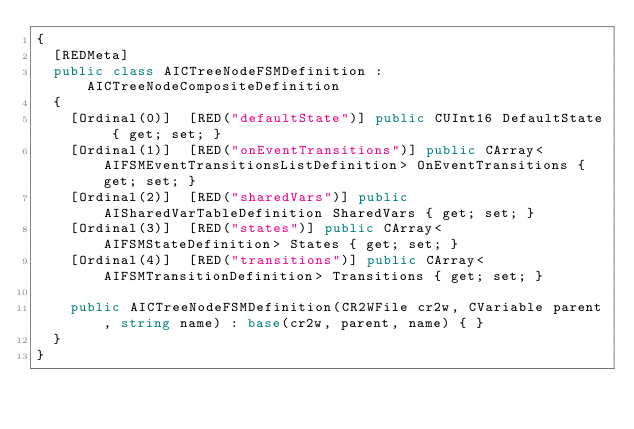<code> <loc_0><loc_0><loc_500><loc_500><_C#_>{
	[REDMeta]
	public class AICTreeNodeFSMDefinition : AICTreeNodeCompositeDefinition
	{
		[Ordinal(0)]  [RED("defaultState")] public CUInt16 DefaultState { get; set; }
		[Ordinal(1)]  [RED("onEventTransitions")] public CArray<AIFSMEventTransitionsListDefinition> OnEventTransitions { get; set; }
		[Ordinal(2)]  [RED("sharedVars")] public AISharedVarTableDefinition SharedVars { get; set; }
		[Ordinal(3)]  [RED("states")] public CArray<AIFSMStateDefinition> States { get; set; }
		[Ordinal(4)]  [RED("transitions")] public CArray<AIFSMTransitionDefinition> Transitions { get; set; }

		public AICTreeNodeFSMDefinition(CR2WFile cr2w, CVariable parent, string name) : base(cr2w, parent, name) { }
	}
}
</code> 